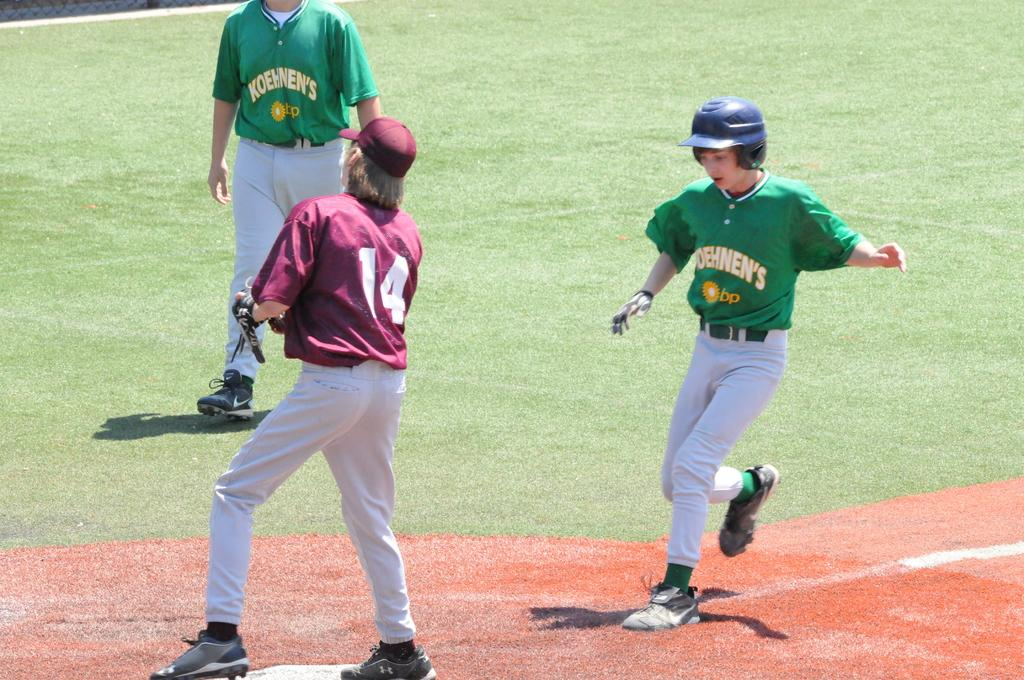Provide a one-sentence caption for the provided image. A baseball player in green approaches the base where 14 is standing. 